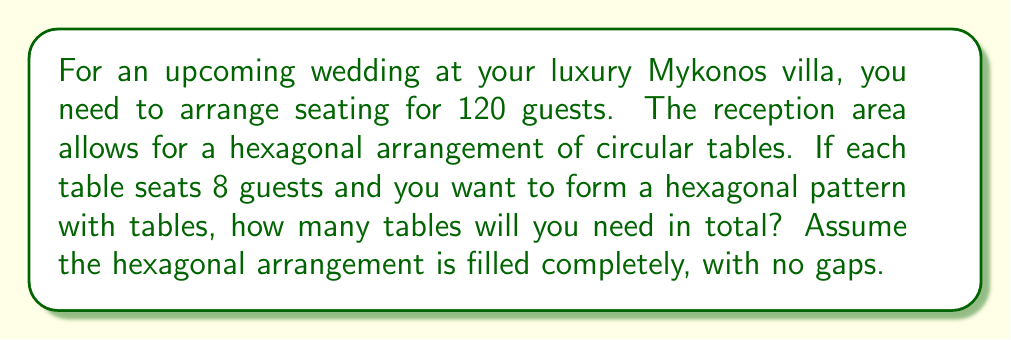Can you solve this math problem? Let's approach this step-by-step:

1) First, we need to understand the pattern of a hexagonal arrangement. The number of objects in a hexagonal pattern follows the centered hexagonal number sequence.

2) The centered hexagonal numbers are given by the formula:
   $$H_n = 3n^2 - 3n + 1$$
   where $n$ is the number of layers in the hexagon.

3) We need to find the smallest hexagonal number that can accommodate all 120 guests.

4) Let's calculate the first few hexagonal numbers:
   For $n = 1$: $H_1 = 3(1)^2 - 3(1) + 1 = 1$
   For $n = 2$: $H_2 = 3(2)^2 - 3(2) + 1 = 7$
   For $n = 3$: $H_3 = 3(3)^2 - 3(3) + 1 = 19$
   For $n = 4$: $H_4 = 3(4)^2 - 3(4) + 1 = 37$

5) We see that $H_4 = 37$ is not enough, so let's continue:
   For $n = 5$: $H_5 = 3(5)^2 - 3(5) + 1 = 61$

6) 61 tables would seat $61 \times 8 = 488$ guests, which is more than enough.

7) Therefore, we need a hexagonal arrangement with 5 layers, totaling 61 tables.

[asy]
unitsize(10mm);
for(int i=0; i<6; ++i) {
  for(int j=0; j<=i; ++j) {
    fill(circle((i-j,j*sqrt(3)), 0.4), gray);
    fill(circle((-i+j,-j*sqrt(3)), 0.4), gray);
  }
}
for(int j=1; j<5; ++j) {
  fill(circle((5-j,j*sqrt(3)), 0.4), gray);
  fill(circle((j-5,-j*sqrt(3)), 0.4), gray);
}
[/asy]
Answer: 61 tables 